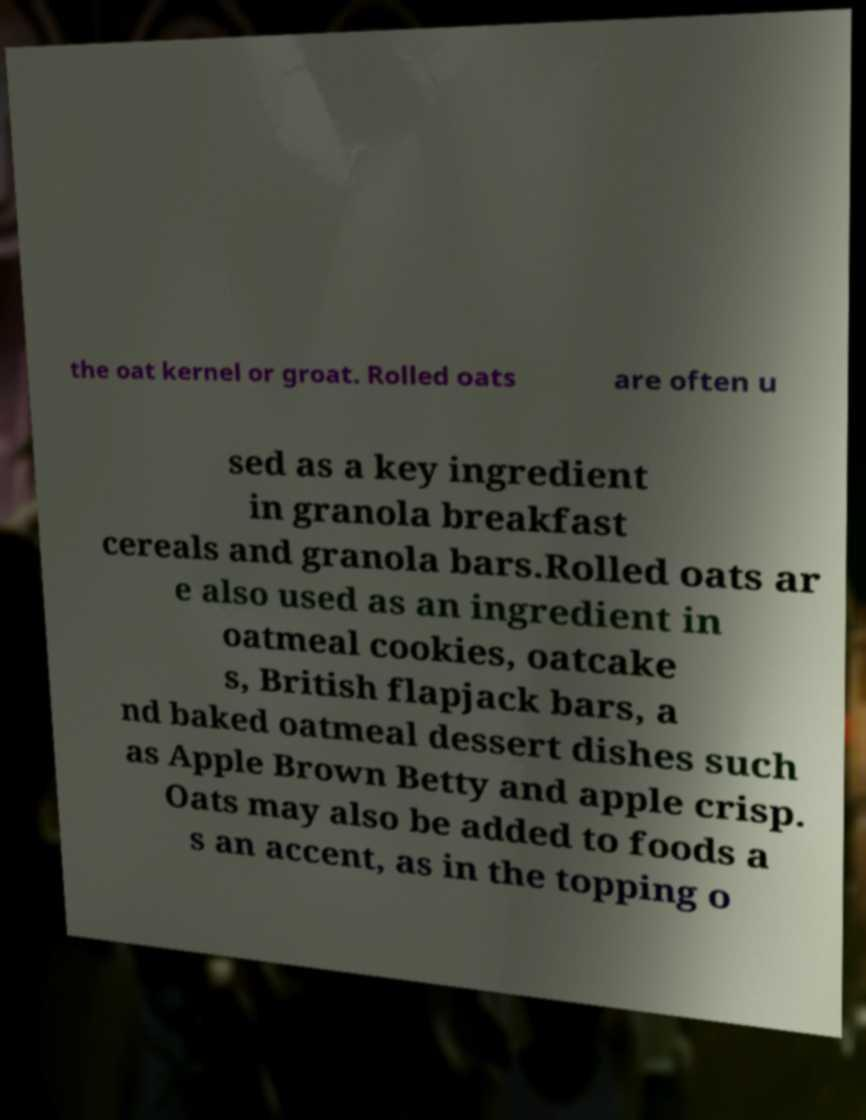I need the written content from this picture converted into text. Can you do that? the oat kernel or groat. Rolled oats are often u sed as a key ingredient in granola breakfast cereals and granola bars.Rolled oats ar e also used as an ingredient in oatmeal cookies, oatcake s, British flapjack bars, a nd baked oatmeal dessert dishes such as Apple Brown Betty and apple crisp. Oats may also be added to foods a s an accent, as in the topping o 